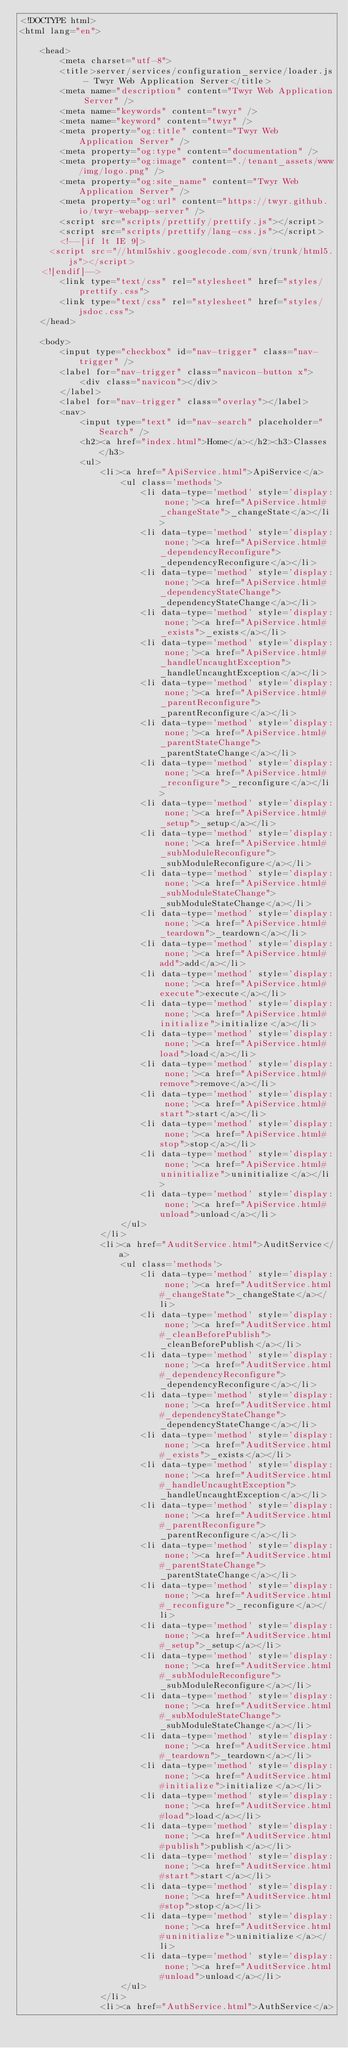<code> <loc_0><loc_0><loc_500><loc_500><_HTML_><!DOCTYPE html>
<html lang="en">

	<head>
		<meta charset="utf-8">
		<title>server/services/configuration_service/loader.js - Twyr Web Application Server</title>
		<meta name="description" content="Twyr Web Application Server" />
		<meta name="keywords" content="twyr" />
		<meta name="keyword" content="twyr" />
		<meta property="og:title" content="Twyr Web Application Server" />
		<meta property="og:type" content="documentation" />
		<meta property="og:image" content="./tenant_assets/www/img/logo.png" />
		<meta property="og:site_name" content="Twyr Web Application Server" />
		<meta property="og:url" content="https://twyr.github.io/twyr-webapp-server" />
		<script src="scripts/prettify/prettify.js"></script>
		<script src="scripts/prettify/lang-css.js"></script>
		<!--[if lt IE 9]>
      <script src="//html5shiv.googlecode.com/svn/trunk/html5.js"></script>
    <![endif]-->
		<link type="text/css" rel="stylesheet" href="styles/prettify.css">
		<link type="text/css" rel="stylesheet" href="styles/jsdoc.css">
	</head>

	<body>
		<input type="checkbox" id="nav-trigger" class="nav-trigger" />
		<label for="nav-trigger" class="navicon-button x">
			<div class="navicon"></div>
		</label>
		<label for="nav-trigger" class="overlay"></label>
		<nav>
			<input type="text" id="nav-search" placeholder="Search" />
			<h2><a href="index.html">Home</a></h2><h3>Classes</h3>
			<ul>
				<li><a href="ApiService.html">ApiService</a>
					<ul class='methods'>
						<li data-type='method' style='display: none;'><a href="ApiService.html#_changeState">_changeState</a></li>
						<li data-type='method' style='display: none;'><a href="ApiService.html#_dependencyReconfigure">_dependencyReconfigure</a></li>
						<li data-type='method' style='display: none;'><a href="ApiService.html#_dependencyStateChange">_dependencyStateChange</a></li>
						<li data-type='method' style='display: none;'><a href="ApiService.html#_exists">_exists</a></li>
						<li data-type='method' style='display: none;'><a href="ApiService.html#_handleUncaughtException">_handleUncaughtException</a></li>
						<li data-type='method' style='display: none;'><a href="ApiService.html#_parentReconfigure">_parentReconfigure</a></li>
						<li data-type='method' style='display: none;'><a href="ApiService.html#_parentStateChange">_parentStateChange</a></li>
						<li data-type='method' style='display: none;'><a href="ApiService.html#_reconfigure">_reconfigure</a></li>
						<li data-type='method' style='display: none;'><a href="ApiService.html#_setup">_setup</a></li>
						<li data-type='method' style='display: none;'><a href="ApiService.html#_subModuleReconfigure">_subModuleReconfigure</a></li>
						<li data-type='method' style='display: none;'><a href="ApiService.html#_subModuleStateChange">_subModuleStateChange</a></li>
						<li data-type='method' style='display: none;'><a href="ApiService.html#_teardown">_teardown</a></li>
						<li data-type='method' style='display: none;'><a href="ApiService.html#add">add</a></li>
						<li data-type='method' style='display: none;'><a href="ApiService.html#execute">execute</a></li>
						<li data-type='method' style='display: none;'><a href="ApiService.html#initialize">initialize</a></li>
						<li data-type='method' style='display: none;'><a href="ApiService.html#load">load</a></li>
						<li data-type='method' style='display: none;'><a href="ApiService.html#remove">remove</a></li>
						<li data-type='method' style='display: none;'><a href="ApiService.html#start">start</a></li>
						<li data-type='method' style='display: none;'><a href="ApiService.html#stop">stop</a></li>
						<li data-type='method' style='display: none;'><a href="ApiService.html#uninitialize">uninitialize</a></li>
						<li data-type='method' style='display: none;'><a href="ApiService.html#unload">unload</a></li>
					</ul>
				</li>
				<li><a href="AuditService.html">AuditService</a>
					<ul class='methods'>
						<li data-type='method' style='display: none;'><a href="AuditService.html#_changeState">_changeState</a></li>
						<li data-type='method' style='display: none;'><a href="AuditService.html#_cleanBeforePublish">_cleanBeforePublish</a></li>
						<li data-type='method' style='display: none;'><a href="AuditService.html#_dependencyReconfigure">_dependencyReconfigure</a></li>
						<li data-type='method' style='display: none;'><a href="AuditService.html#_dependencyStateChange">_dependencyStateChange</a></li>
						<li data-type='method' style='display: none;'><a href="AuditService.html#_exists">_exists</a></li>
						<li data-type='method' style='display: none;'><a href="AuditService.html#_handleUncaughtException">_handleUncaughtException</a></li>
						<li data-type='method' style='display: none;'><a href="AuditService.html#_parentReconfigure">_parentReconfigure</a></li>
						<li data-type='method' style='display: none;'><a href="AuditService.html#_parentStateChange">_parentStateChange</a></li>
						<li data-type='method' style='display: none;'><a href="AuditService.html#_reconfigure">_reconfigure</a></li>
						<li data-type='method' style='display: none;'><a href="AuditService.html#_setup">_setup</a></li>
						<li data-type='method' style='display: none;'><a href="AuditService.html#_subModuleReconfigure">_subModuleReconfigure</a></li>
						<li data-type='method' style='display: none;'><a href="AuditService.html#_subModuleStateChange">_subModuleStateChange</a></li>
						<li data-type='method' style='display: none;'><a href="AuditService.html#_teardown">_teardown</a></li>
						<li data-type='method' style='display: none;'><a href="AuditService.html#initialize">initialize</a></li>
						<li data-type='method' style='display: none;'><a href="AuditService.html#load">load</a></li>
						<li data-type='method' style='display: none;'><a href="AuditService.html#publish">publish</a></li>
						<li data-type='method' style='display: none;'><a href="AuditService.html#start">start</a></li>
						<li data-type='method' style='display: none;'><a href="AuditService.html#stop">stop</a></li>
						<li data-type='method' style='display: none;'><a href="AuditService.html#uninitialize">uninitialize</a></li>
						<li data-type='method' style='display: none;'><a href="AuditService.html#unload">unload</a></li>
					</ul>
				</li>
				<li><a href="AuthService.html">AuthService</a></code> 